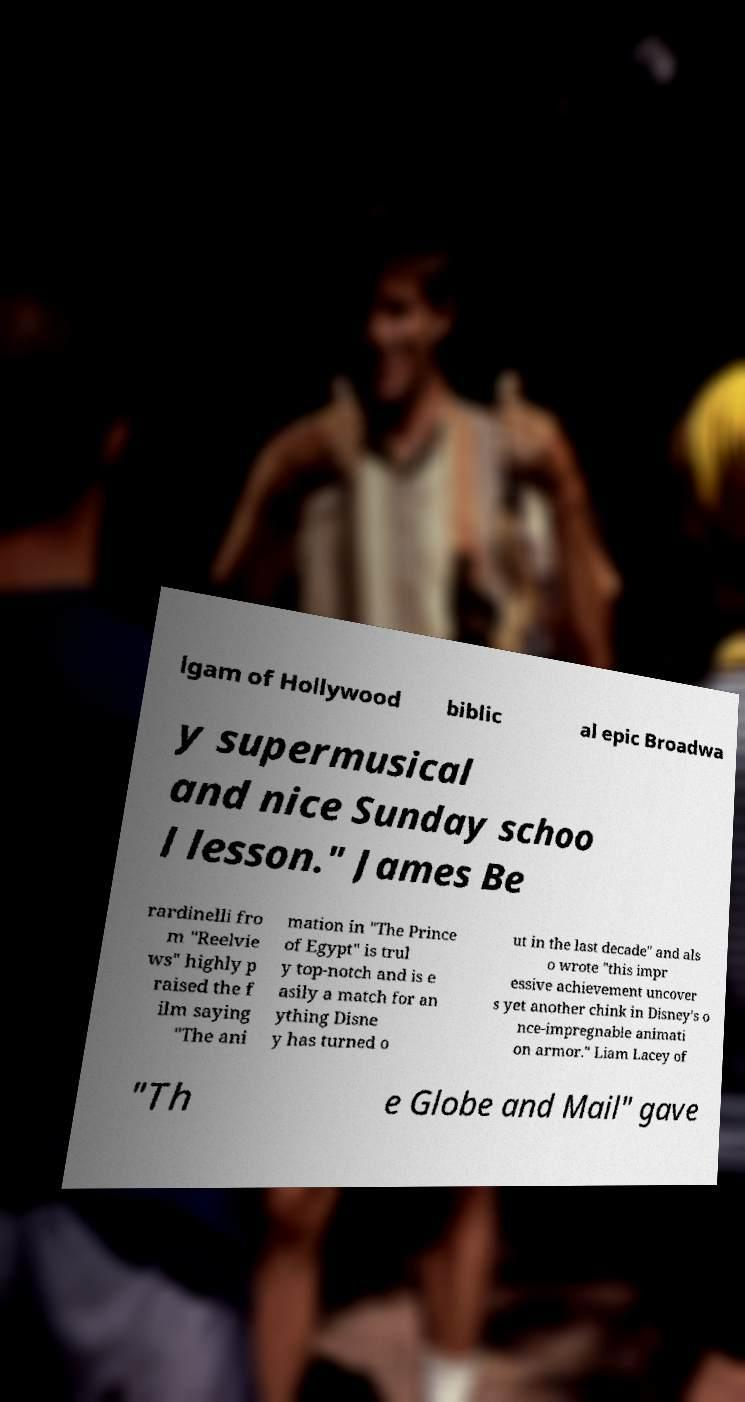What messages or text are displayed in this image? I need them in a readable, typed format. lgam of Hollywood biblic al epic Broadwa y supermusical and nice Sunday schoo l lesson." James Be rardinelli fro m "Reelvie ws" highly p raised the f ilm saying "The ani mation in "The Prince of Egypt" is trul y top-notch and is e asily a match for an ything Disne y has turned o ut in the last decade" and als o wrote "this impr essive achievement uncover s yet another chink in Disney's o nce-impregnable animati on armor." Liam Lacey of "Th e Globe and Mail" gave 